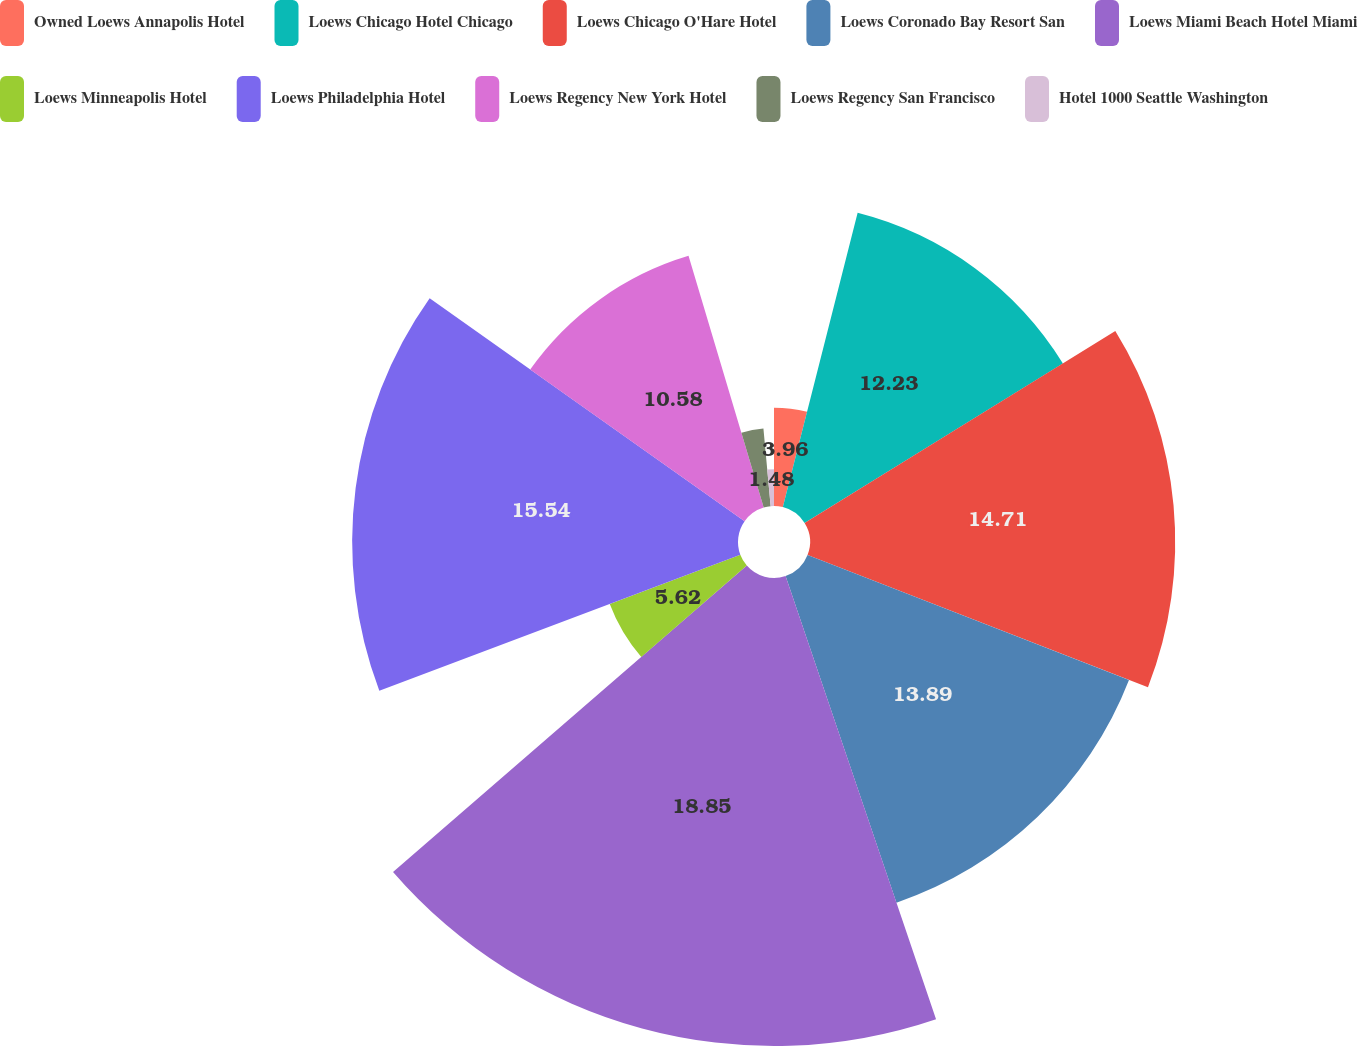Convert chart. <chart><loc_0><loc_0><loc_500><loc_500><pie_chart><fcel>Owned Loews Annapolis Hotel<fcel>Loews Chicago Hotel Chicago<fcel>Loews Chicago O'Hare Hotel<fcel>Loews Coronado Bay Resort San<fcel>Loews Miami Beach Hotel Miami<fcel>Loews Minneapolis Hotel<fcel>Loews Philadelphia Hotel<fcel>Loews Regency New York Hotel<fcel>Loews Regency San Francisco<fcel>Hotel 1000 Seattle Washington<nl><fcel>3.96%<fcel>12.23%<fcel>14.71%<fcel>13.89%<fcel>18.85%<fcel>5.62%<fcel>15.54%<fcel>10.58%<fcel>3.14%<fcel>1.48%<nl></chart> 